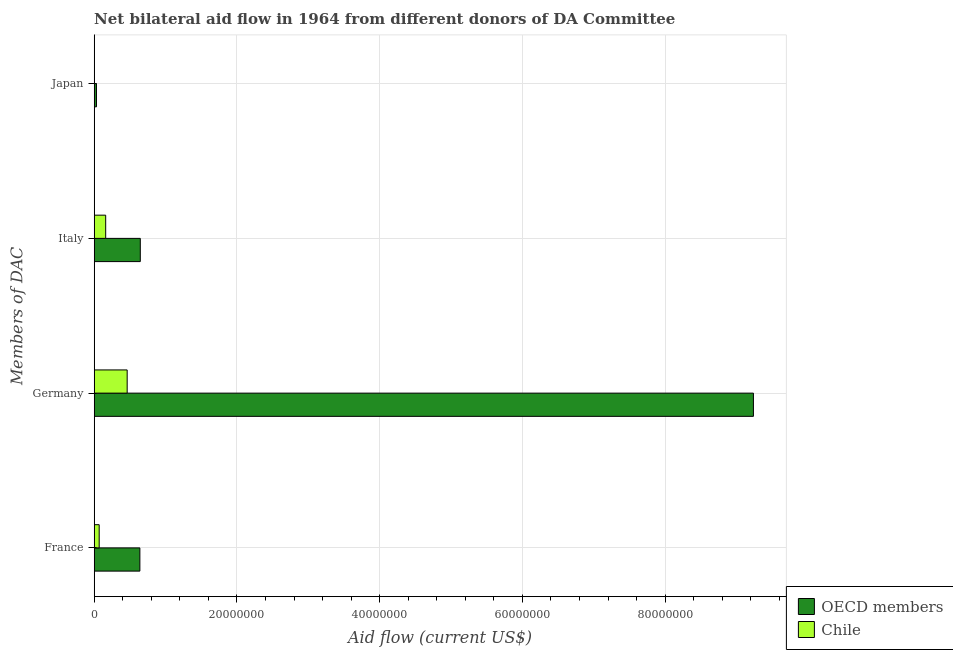How many different coloured bars are there?
Keep it short and to the point. 2. How many groups of bars are there?
Your answer should be compact. 4. Are the number of bars per tick equal to the number of legend labels?
Keep it short and to the point. Yes. How many bars are there on the 4th tick from the top?
Offer a very short reply. 2. What is the amount of aid given by france in Chile?
Make the answer very short. 7.00e+05. Across all countries, what is the maximum amount of aid given by germany?
Your response must be concise. 9.24e+07. Across all countries, what is the minimum amount of aid given by italy?
Offer a terse response. 1.61e+06. What is the total amount of aid given by japan in the graph?
Keep it short and to the point. 3.60e+05. What is the difference between the amount of aid given by japan in OECD members and that in Chile?
Your response must be concise. 2.80e+05. What is the difference between the amount of aid given by france in Chile and the amount of aid given by germany in OECD members?
Provide a succinct answer. -9.17e+07. What is the average amount of aid given by france per country?
Provide a succinct answer. 3.55e+06. What is the difference between the amount of aid given by japan and amount of aid given by italy in OECD members?
Keep it short and to the point. -6.14e+06. What is the ratio of the amount of aid given by france in Chile to that in OECD members?
Your answer should be compact. 0.11. What is the difference between the highest and the second highest amount of aid given by france?
Make the answer very short. 5.70e+06. What is the difference between the highest and the lowest amount of aid given by italy?
Provide a succinct answer. 4.85e+06. Is it the case that in every country, the sum of the amount of aid given by germany and amount of aid given by japan is greater than the sum of amount of aid given by france and amount of aid given by italy?
Your response must be concise. Yes. What does the 2nd bar from the top in Italy represents?
Provide a short and direct response. OECD members. What does the 2nd bar from the bottom in Germany represents?
Make the answer very short. Chile. Is it the case that in every country, the sum of the amount of aid given by france and amount of aid given by germany is greater than the amount of aid given by italy?
Make the answer very short. Yes. How many countries are there in the graph?
Ensure brevity in your answer.  2. What is the title of the graph?
Your answer should be compact. Net bilateral aid flow in 1964 from different donors of DA Committee. Does "Congo (Democratic)" appear as one of the legend labels in the graph?
Offer a very short reply. No. What is the label or title of the X-axis?
Offer a terse response. Aid flow (current US$). What is the label or title of the Y-axis?
Give a very brief answer. Members of DAC. What is the Aid flow (current US$) of OECD members in France?
Your answer should be very brief. 6.40e+06. What is the Aid flow (current US$) of OECD members in Germany?
Make the answer very short. 9.24e+07. What is the Aid flow (current US$) of Chile in Germany?
Your answer should be compact. 4.62e+06. What is the Aid flow (current US$) of OECD members in Italy?
Your response must be concise. 6.46e+06. What is the Aid flow (current US$) of Chile in Italy?
Ensure brevity in your answer.  1.61e+06. What is the Aid flow (current US$) in OECD members in Japan?
Your answer should be very brief. 3.20e+05. Across all Members of DAC, what is the maximum Aid flow (current US$) in OECD members?
Ensure brevity in your answer.  9.24e+07. Across all Members of DAC, what is the maximum Aid flow (current US$) of Chile?
Ensure brevity in your answer.  4.62e+06. Across all Members of DAC, what is the minimum Aid flow (current US$) in OECD members?
Provide a succinct answer. 3.20e+05. What is the total Aid flow (current US$) in OECD members in the graph?
Keep it short and to the point. 1.06e+08. What is the total Aid flow (current US$) in Chile in the graph?
Your response must be concise. 6.97e+06. What is the difference between the Aid flow (current US$) in OECD members in France and that in Germany?
Make the answer very short. -8.60e+07. What is the difference between the Aid flow (current US$) in Chile in France and that in Germany?
Offer a terse response. -3.92e+06. What is the difference between the Aid flow (current US$) in OECD members in France and that in Italy?
Give a very brief answer. -6.00e+04. What is the difference between the Aid flow (current US$) in Chile in France and that in Italy?
Offer a very short reply. -9.10e+05. What is the difference between the Aid flow (current US$) of OECD members in France and that in Japan?
Make the answer very short. 6.08e+06. What is the difference between the Aid flow (current US$) of Chile in France and that in Japan?
Make the answer very short. 6.60e+05. What is the difference between the Aid flow (current US$) of OECD members in Germany and that in Italy?
Your answer should be very brief. 8.59e+07. What is the difference between the Aid flow (current US$) of Chile in Germany and that in Italy?
Offer a terse response. 3.01e+06. What is the difference between the Aid flow (current US$) of OECD members in Germany and that in Japan?
Your answer should be very brief. 9.20e+07. What is the difference between the Aid flow (current US$) of Chile in Germany and that in Japan?
Keep it short and to the point. 4.58e+06. What is the difference between the Aid flow (current US$) in OECD members in Italy and that in Japan?
Your answer should be very brief. 6.14e+06. What is the difference between the Aid flow (current US$) in Chile in Italy and that in Japan?
Provide a short and direct response. 1.57e+06. What is the difference between the Aid flow (current US$) in OECD members in France and the Aid flow (current US$) in Chile in Germany?
Provide a short and direct response. 1.78e+06. What is the difference between the Aid flow (current US$) of OECD members in France and the Aid flow (current US$) of Chile in Italy?
Your answer should be compact. 4.79e+06. What is the difference between the Aid flow (current US$) in OECD members in France and the Aid flow (current US$) in Chile in Japan?
Give a very brief answer. 6.36e+06. What is the difference between the Aid flow (current US$) of OECD members in Germany and the Aid flow (current US$) of Chile in Italy?
Provide a short and direct response. 9.08e+07. What is the difference between the Aid flow (current US$) of OECD members in Germany and the Aid flow (current US$) of Chile in Japan?
Keep it short and to the point. 9.23e+07. What is the difference between the Aid flow (current US$) in OECD members in Italy and the Aid flow (current US$) in Chile in Japan?
Offer a very short reply. 6.42e+06. What is the average Aid flow (current US$) in OECD members per Members of DAC?
Your answer should be very brief. 2.64e+07. What is the average Aid flow (current US$) of Chile per Members of DAC?
Give a very brief answer. 1.74e+06. What is the difference between the Aid flow (current US$) in OECD members and Aid flow (current US$) in Chile in France?
Make the answer very short. 5.70e+06. What is the difference between the Aid flow (current US$) in OECD members and Aid flow (current US$) in Chile in Germany?
Your response must be concise. 8.78e+07. What is the difference between the Aid flow (current US$) of OECD members and Aid flow (current US$) of Chile in Italy?
Provide a short and direct response. 4.85e+06. What is the difference between the Aid flow (current US$) in OECD members and Aid flow (current US$) in Chile in Japan?
Your response must be concise. 2.80e+05. What is the ratio of the Aid flow (current US$) of OECD members in France to that in Germany?
Provide a succinct answer. 0.07. What is the ratio of the Aid flow (current US$) of Chile in France to that in Germany?
Provide a short and direct response. 0.15. What is the ratio of the Aid flow (current US$) of OECD members in France to that in Italy?
Your response must be concise. 0.99. What is the ratio of the Aid flow (current US$) in Chile in France to that in Italy?
Your answer should be very brief. 0.43. What is the ratio of the Aid flow (current US$) of OECD members in France to that in Japan?
Make the answer very short. 20. What is the ratio of the Aid flow (current US$) of Chile in France to that in Japan?
Your answer should be compact. 17.5. What is the ratio of the Aid flow (current US$) of OECD members in Germany to that in Italy?
Keep it short and to the point. 14.3. What is the ratio of the Aid flow (current US$) in Chile in Germany to that in Italy?
Make the answer very short. 2.87. What is the ratio of the Aid flow (current US$) of OECD members in Germany to that in Japan?
Your answer should be very brief. 288.66. What is the ratio of the Aid flow (current US$) in Chile in Germany to that in Japan?
Your answer should be compact. 115.5. What is the ratio of the Aid flow (current US$) of OECD members in Italy to that in Japan?
Your answer should be compact. 20.19. What is the ratio of the Aid flow (current US$) in Chile in Italy to that in Japan?
Provide a succinct answer. 40.25. What is the difference between the highest and the second highest Aid flow (current US$) in OECD members?
Your answer should be very brief. 8.59e+07. What is the difference between the highest and the second highest Aid flow (current US$) in Chile?
Your answer should be compact. 3.01e+06. What is the difference between the highest and the lowest Aid flow (current US$) in OECD members?
Make the answer very short. 9.20e+07. What is the difference between the highest and the lowest Aid flow (current US$) in Chile?
Ensure brevity in your answer.  4.58e+06. 